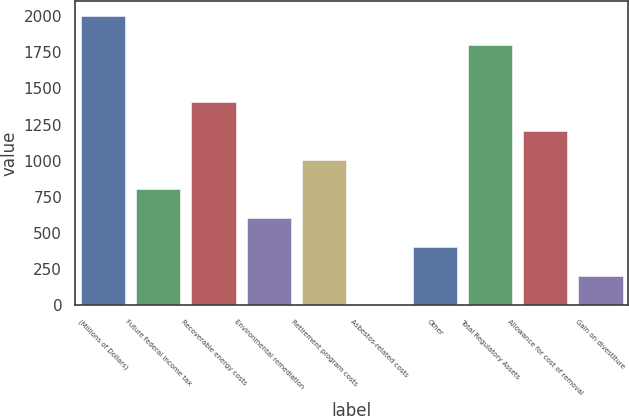Convert chart. <chart><loc_0><loc_0><loc_500><loc_500><bar_chart><fcel>(Millions of Dollars)<fcel>Future federal income tax<fcel>Recoverable energy costs<fcel>Environmental remediation<fcel>Retirement program costs<fcel>Asbestos-related costs<fcel>Other<fcel>Total Regulatory Assets<fcel>Allowance for cost of removal<fcel>Gain on divestiture<nl><fcel>2003<fcel>801.8<fcel>1402.4<fcel>601.6<fcel>1002<fcel>1<fcel>401.4<fcel>1802.8<fcel>1202.2<fcel>201.2<nl></chart> 